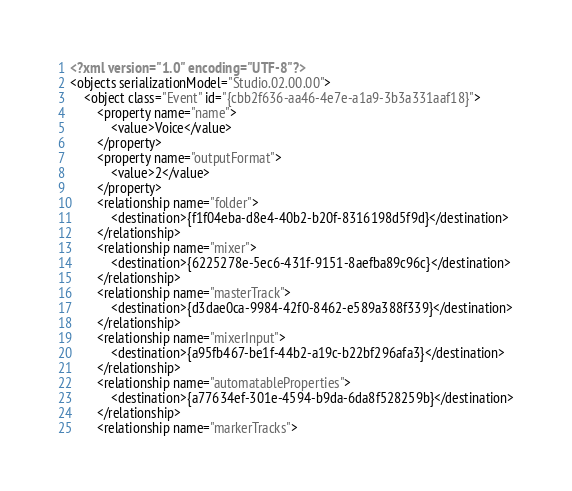<code> <loc_0><loc_0><loc_500><loc_500><_XML_><?xml version="1.0" encoding="UTF-8"?>
<objects serializationModel="Studio.02.00.00">
	<object class="Event" id="{cbb2f636-aa46-4e7e-a1a9-3b3a331aaf18}">
		<property name="name">
			<value>Voice</value>
		</property>
		<property name="outputFormat">
			<value>2</value>
		</property>
		<relationship name="folder">
			<destination>{f1f04eba-d8e4-40b2-b20f-8316198d5f9d}</destination>
		</relationship>
		<relationship name="mixer">
			<destination>{6225278e-5ec6-431f-9151-8aefba89c96c}</destination>
		</relationship>
		<relationship name="masterTrack">
			<destination>{d3dae0ca-9984-42f0-8462-e589a388f339}</destination>
		</relationship>
		<relationship name="mixerInput">
			<destination>{a95fb467-be1f-44b2-a19c-b22bf296afa3}</destination>
		</relationship>
		<relationship name="automatableProperties">
			<destination>{a77634ef-301e-4594-b9da-6da8f528259b}</destination>
		</relationship>
		<relationship name="markerTracks"></code> 